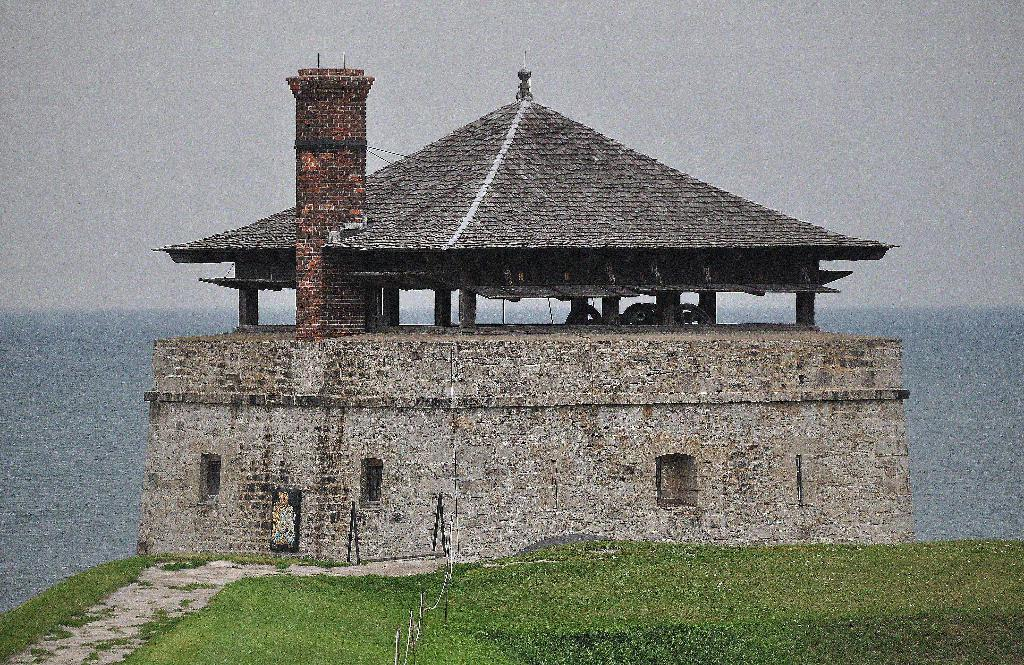What type of landscape is depicted in the image? There is a grassland in the image. What structures can be seen in the background of the image? There is a house in the background of the image. What natural feature is visible in the background of the image? The sea is visible in the background of the image. What type of lace can be seen decorating the house in the image? There is no lace visible on the house in the image. 